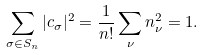Convert formula to latex. <formula><loc_0><loc_0><loc_500><loc_500>\sum _ { \sigma \in S _ { n } } | c _ { \sigma } | ^ { 2 } = \frac { 1 } { n ! } \sum _ { \nu } n _ { \nu } ^ { 2 } = 1 .</formula> 